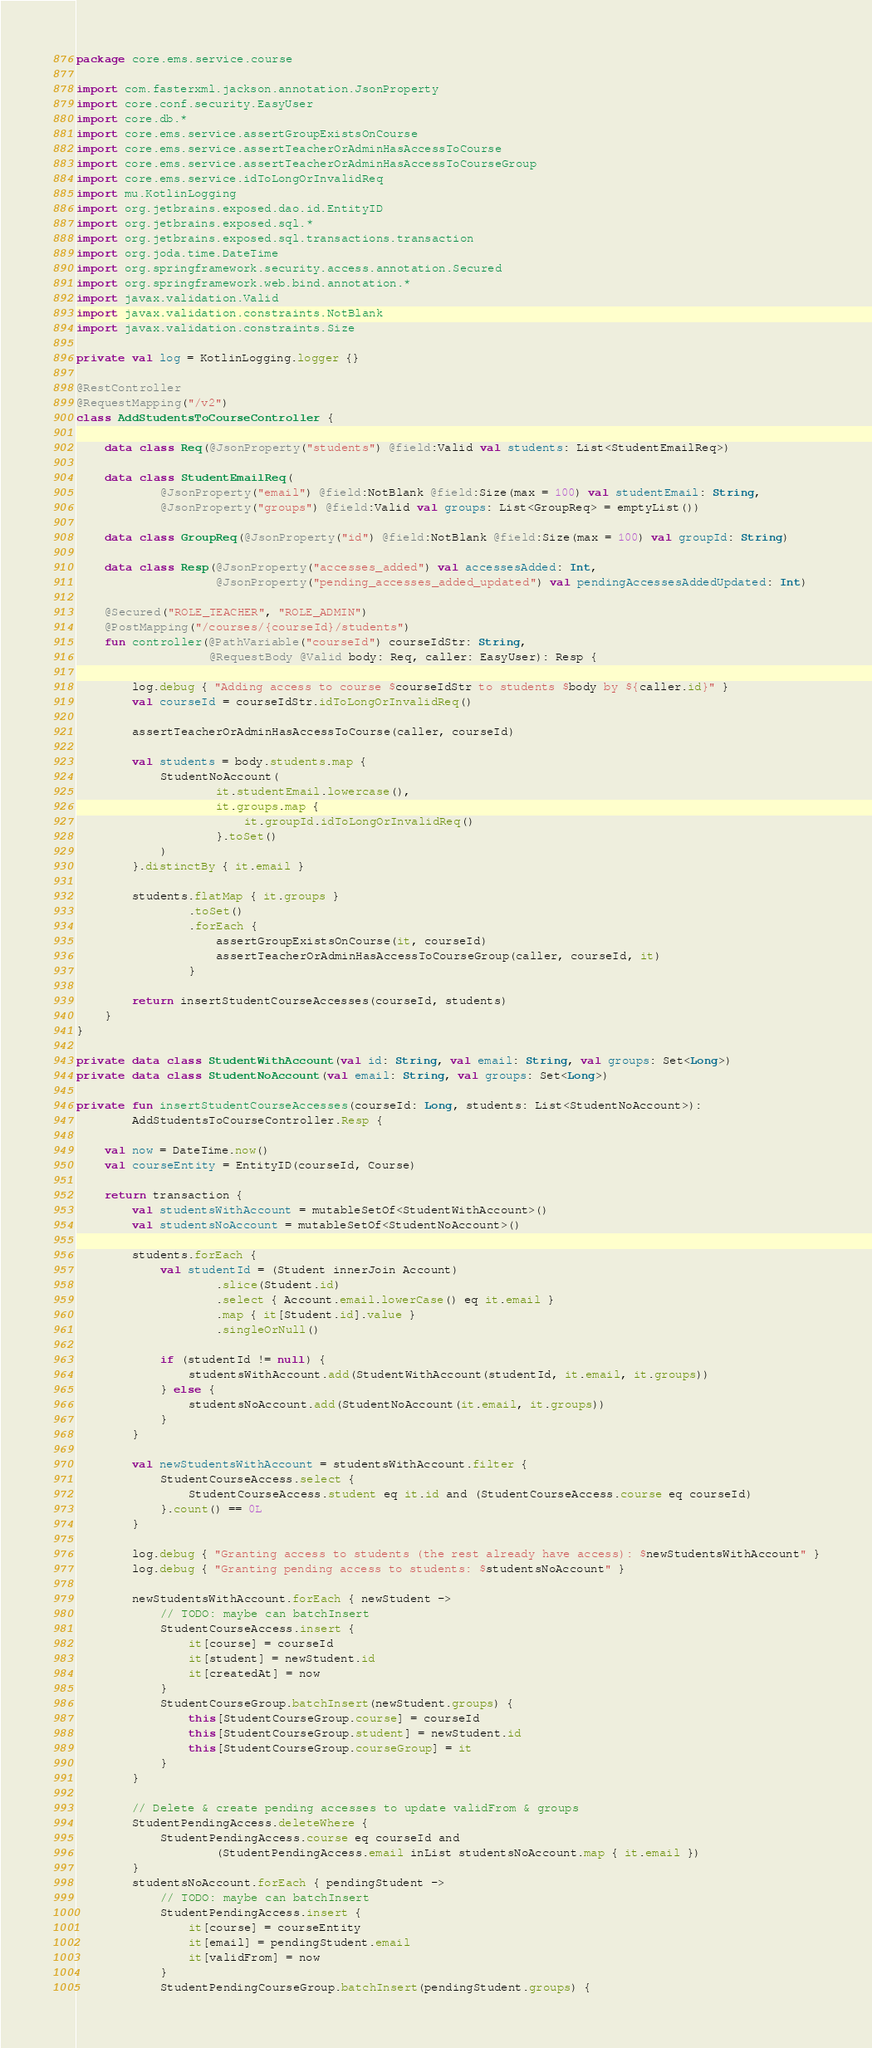<code> <loc_0><loc_0><loc_500><loc_500><_Kotlin_>package core.ems.service.course

import com.fasterxml.jackson.annotation.JsonProperty
import core.conf.security.EasyUser
import core.db.*
import core.ems.service.assertGroupExistsOnCourse
import core.ems.service.assertTeacherOrAdminHasAccessToCourse
import core.ems.service.assertTeacherOrAdminHasAccessToCourseGroup
import core.ems.service.idToLongOrInvalidReq
import mu.KotlinLogging
import org.jetbrains.exposed.dao.id.EntityID
import org.jetbrains.exposed.sql.*
import org.jetbrains.exposed.sql.transactions.transaction
import org.joda.time.DateTime
import org.springframework.security.access.annotation.Secured
import org.springframework.web.bind.annotation.*
import javax.validation.Valid
import javax.validation.constraints.NotBlank
import javax.validation.constraints.Size

private val log = KotlinLogging.logger {}

@RestController
@RequestMapping("/v2")
class AddStudentsToCourseController {

    data class Req(@JsonProperty("students") @field:Valid val students: List<StudentEmailReq>)

    data class StudentEmailReq(
            @JsonProperty("email") @field:NotBlank @field:Size(max = 100) val studentEmail: String,
            @JsonProperty("groups") @field:Valid val groups: List<GroupReq> = emptyList())

    data class GroupReq(@JsonProperty("id") @field:NotBlank @field:Size(max = 100) val groupId: String)

    data class Resp(@JsonProperty("accesses_added") val accessesAdded: Int,
                    @JsonProperty("pending_accesses_added_updated") val pendingAccessesAddedUpdated: Int)

    @Secured("ROLE_TEACHER", "ROLE_ADMIN")
    @PostMapping("/courses/{courseId}/students")
    fun controller(@PathVariable("courseId") courseIdStr: String,
                   @RequestBody @Valid body: Req, caller: EasyUser): Resp {

        log.debug { "Adding access to course $courseIdStr to students $body by ${caller.id}" }
        val courseId = courseIdStr.idToLongOrInvalidReq()

        assertTeacherOrAdminHasAccessToCourse(caller, courseId)

        val students = body.students.map {
            StudentNoAccount(
                    it.studentEmail.lowercase(),
                    it.groups.map {
                        it.groupId.idToLongOrInvalidReq()
                    }.toSet()
            )
        }.distinctBy { it.email }

        students.flatMap { it.groups }
                .toSet()
                .forEach {
                    assertGroupExistsOnCourse(it, courseId)
                    assertTeacherOrAdminHasAccessToCourseGroup(caller, courseId, it)
                }

        return insertStudentCourseAccesses(courseId, students)
    }
}

private data class StudentWithAccount(val id: String, val email: String, val groups: Set<Long>)
private data class StudentNoAccount(val email: String, val groups: Set<Long>)

private fun insertStudentCourseAccesses(courseId: Long, students: List<StudentNoAccount>):
        AddStudentsToCourseController.Resp {

    val now = DateTime.now()
    val courseEntity = EntityID(courseId, Course)

    return transaction {
        val studentsWithAccount = mutableSetOf<StudentWithAccount>()
        val studentsNoAccount = mutableSetOf<StudentNoAccount>()

        students.forEach {
            val studentId = (Student innerJoin Account)
                    .slice(Student.id)
                    .select { Account.email.lowerCase() eq it.email }
                    .map { it[Student.id].value }
                    .singleOrNull()

            if (studentId != null) {
                studentsWithAccount.add(StudentWithAccount(studentId, it.email, it.groups))
            } else {
                studentsNoAccount.add(StudentNoAccount(it.email, it.groups))
            }
        }

        val newStudentsWithAccount = studentsWithAccount.filter {
            StudentCourseAccess.select {
                StudentCourseAccess.student eq it.id and (StudentCourseAccess.course eq courseId)
            }.count() == 0L
        }

        log.debug { "Granting access to students (the rest already have access): $newStudentsWithAccount" }
        log.debug { "Granting pending access to students: $studentsNoAccount" }

        newStudentsWithAccount.forEach { newStudent ->
            // TODO: maybe can batchInsert
            StudentCourseAccess.insert {
                it[course] = courseId
                it[student] = newStudent.id
                it[createdAt] = now
            }
            StudentCourseGroup.batchInsert(newStudent.groups) {
                this[StudentCourseGroup.course] = courseId
                this[StudentCourseGroup.student] = newStudent.id
                this[StudentCourseGroup.courseGroup] = it
            }
        }

        // Delete & create pending accesses to update validFrom & groups
        StudentPendingAccess.deleteWhere {
            StudentPendingAccess.course eq courseId and
                    (StudentPendingAccess.email inList studentsNoAccount.map { it.email })
        }
        studentsNoAccount.forEach { pendingStudent ->
            // TODO: maybe can batchInsert
            StudentPendingAccess.insert {
                it[course] = courseEntity
                it[email] = pendingStudent.email
                it[validFrom] = now
            }
            StudentPendingCourseGroup.batchInsert(pendingStudent.groups) {</code> 